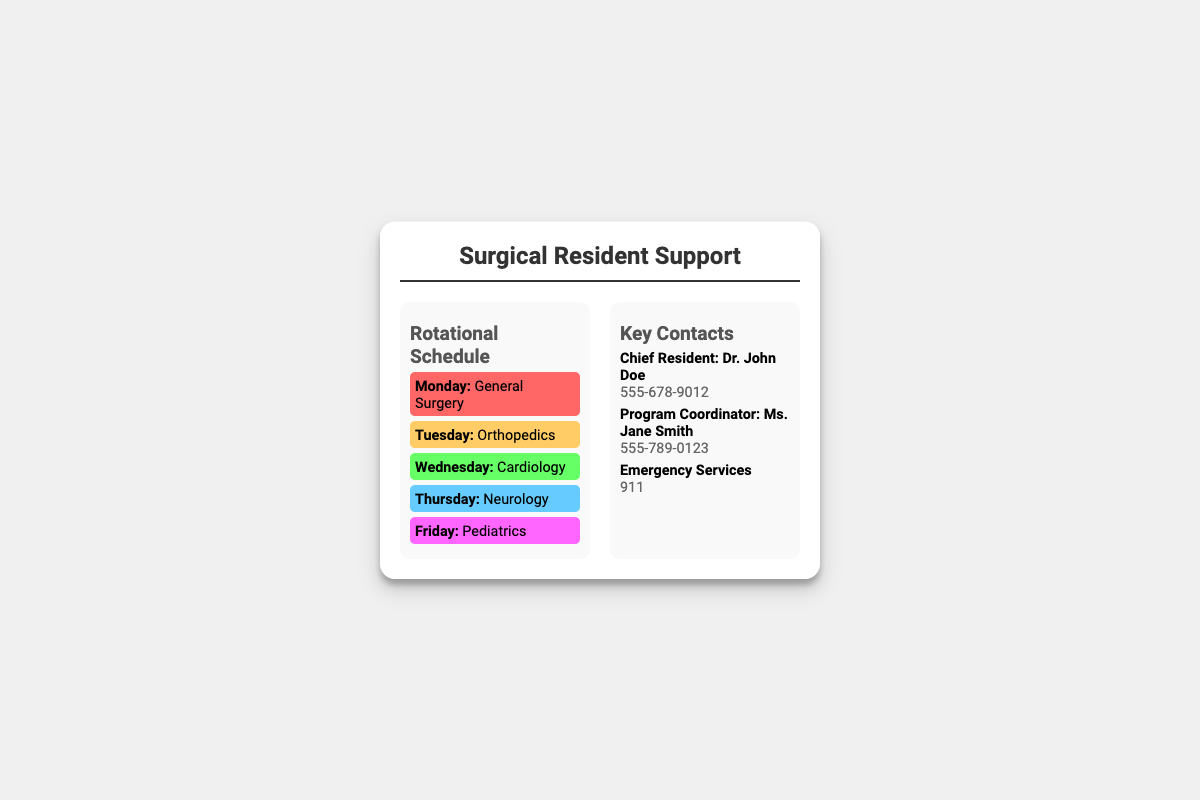What is the name of the Chief Resident? The Chief Resident's name is mentioned in the Key Contacts section of the document as Dr. John Doe.
Answer: Dr. John Doe What is the phone number for Emergency Services? The phone number for Emergency Services is provided in the Key Contacts section.
Answer: 911 Which department is scheduled for Tuesday? The document outlines the rotational schedule, where Tuesday corresponds to Orthopedics.
Answer: Orthopedics What color represents Cardiology on the schedule? The background color for Wednesday, which is Cardiology, is given in the rotational schedule.
Answer: Green Who is the Program Coordinator? The name of the Program Coordinator is listed in the Key Contacts section as Ms. Jane Smith.
Answer: Ms. Jane Smith On which day do residents work in Pediatrics? The document clearly states that Pediatrics is scheduled for Friday.
Answer: Friday How many departments are listed in the Rotational Schedule? The document lists a total of five departments across the different days.
Answer: Five What is the title of the document? The title of the document is displayed prominently at the top as "Surgical Resident Support."
Answer: Surgical Resident Support Which day has the color #FF6666 in the schedule? The document indicates that Monday's schedule background color is #FF6666, which corresponds to General Surgery.
Answer: Monday 